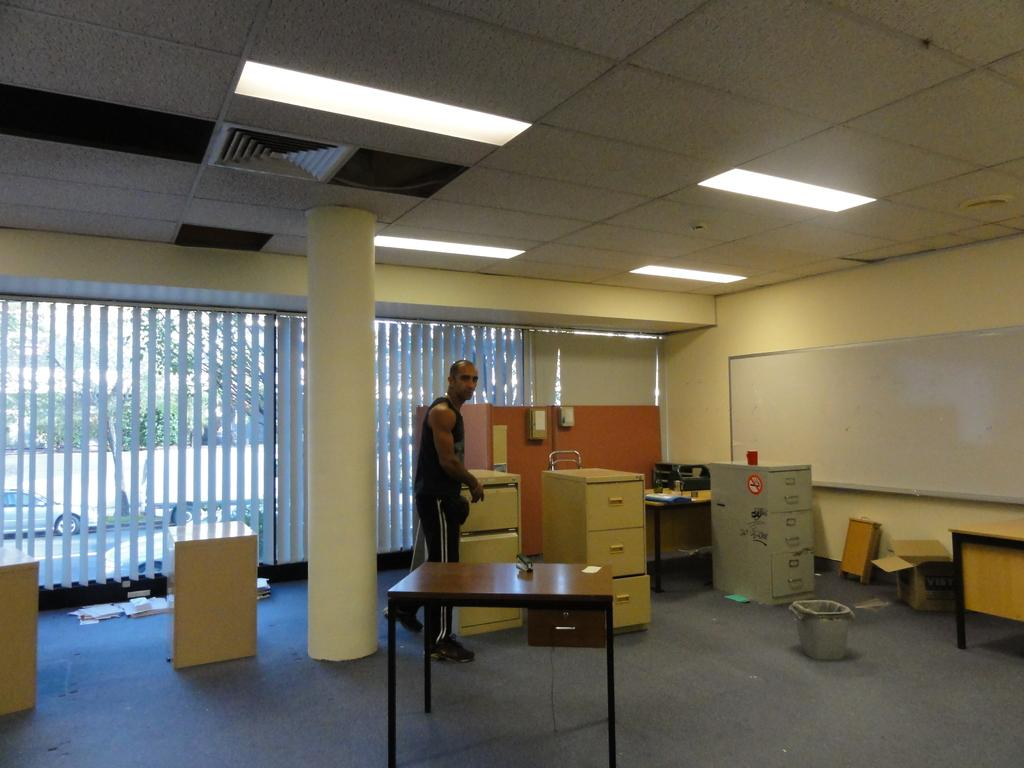What is the position of the person in the image? The person is standing in the image. What surface is the person standing on? The person is standing on the floor. What object is in front of the person? There is a table in front of the person. What architectural feature can be seen in the image? There is a pillar and a wall in the image. What is attached to the wall? There is a board on the wall. What is visible above the person? There are lights visible above the person. What type of wine is being offered to the person in the image? There is no wine present in the image, and no one is offering anything to the person. 